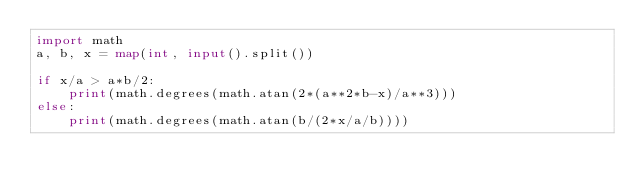<code> <loc_0><loc_0><loc_500><loc_500><_Python_>import math
a, b, x = map(int, input().split())
 
if x/a > a*b/2:
    print(math.degrees(math.atan(2*(a**2*b-x)/a**3)))
else:
    print(math.degrees(math.atan(b/(2*x/a/b))))</code> 